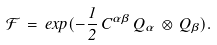<formula> <loc_0><loc_0><loc_500><loc_500>\mathcal { F } \, = \, e x p ( - \frac { 1 } { 2 } \, C ^ { \alpha \beta } \, Q _ { \alpha } \, \otimes \, Q _ { \beta } ) .</formula> 